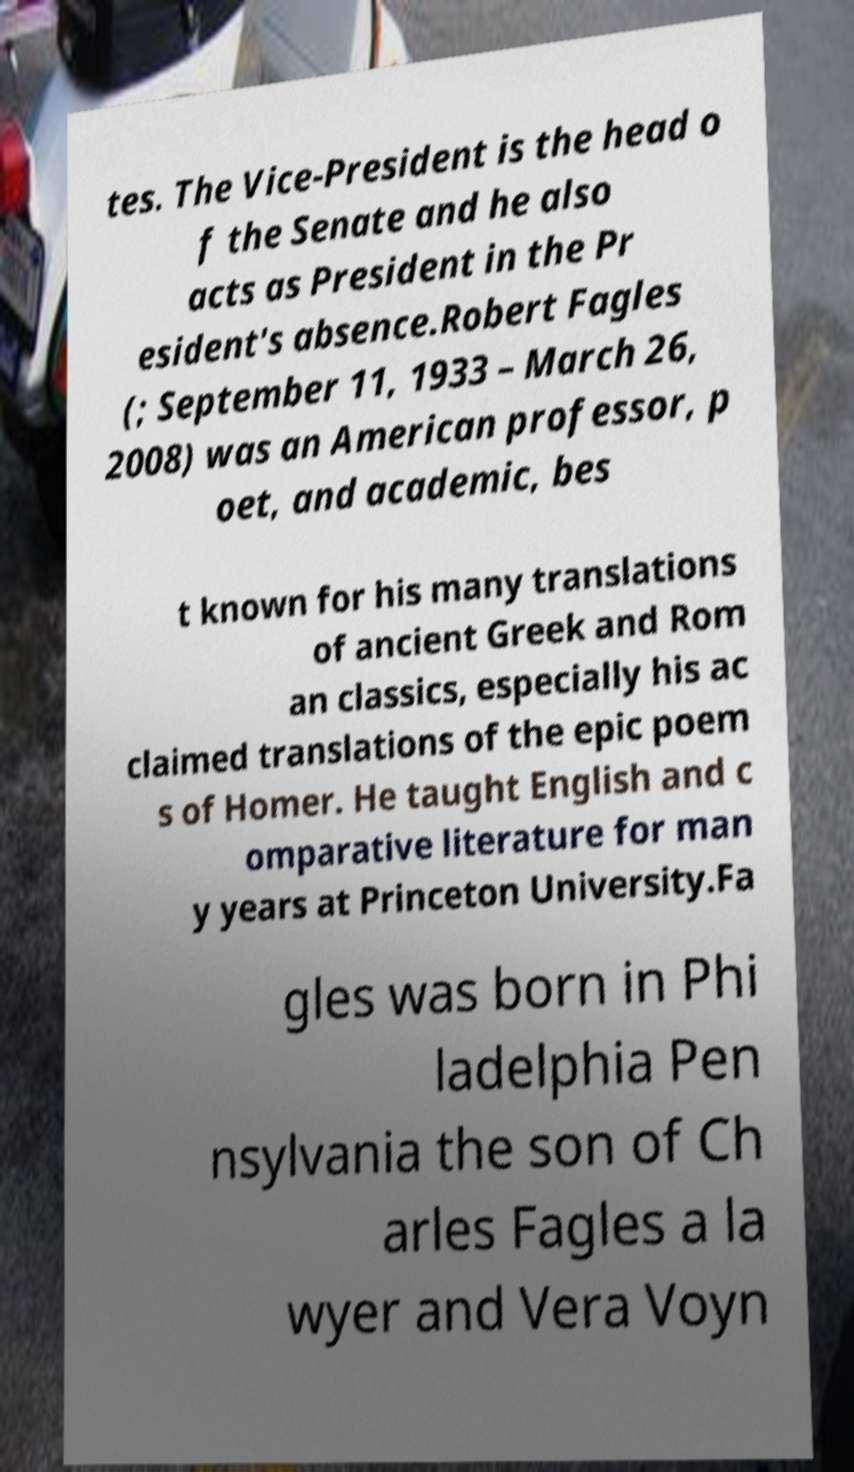I need the written content from this picture converted into text. Can you do that? tes. The Vice-President is the head o f the Senate and he also acts as President in the Pr esident's absence.Robert Fagles (; September 11, 1933 – March 26, 2008) was an American professor, p oet, and academic, bes t known for his many translations of ancient Greek and Rom an classics, especially his ac claimed translations of the epic poem s of Homer. He taught English and c omparative literature for man y years at Princeton University.Fa gles was born in Phi ladelphia Pen nsylvania the son of Ch arles Fagles a la wyer and Vera Voyn 